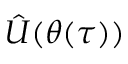Convert formula to latex. <formula><loc_0><loc_0><loc_500><loc_500>\hat { U } ( \theta ( \tau ) )</formula> 